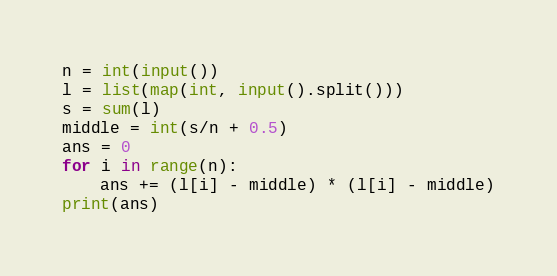<code> <loc_0><loc_0><loc_500><loc_500><_Python_>n = int(input())
l = list(map(int, input().split()))
s = sum(l)
middle = int(s/n + 0.5)
ans = 0
for i in range(n):
	ans += (l[i] - middle) * (l[i] - middle)
print(ans)</code> 